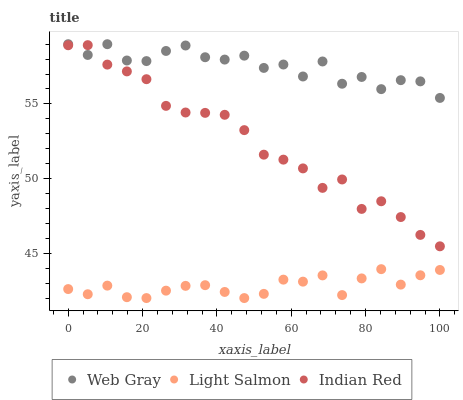Does Light Salmon have the minimum area under the curve?
Answer yes or no. Yes. Does Web Gray have the maximum area under the curve?
Answer yes or no. Yes. Does Indian Red have the minimum area under the curve?
Answer yes or no. No. Does Indian Red have the maximum area under the curve?
Answer yes or no. No. Is Light Salmon the smoothest?
Answer yes or no. Yes. Is Web Gray the roughest?
Answer yes or no. Yes. Is Indian Red the smoothest?
Answer yes or no. No. Is Indian Red the roughest?
Answer yes or no. No. Does Light Salmon have the lowest value?
Answer yes or no. Yes. Does Indian Red have the lowest value?
Answer yes or no. No. Does Web Gray have the highest value?
Answer yes or no. Yes. Does Indian Red have the highest value?
Answer yes or no. No. Is Light Salmon less than Indian Red?
Answer yes or no. Yes. Is Indian Red greater than Light Salmon?
Answer yes or no. Yes. Does Indian Red intersect Web Gray?
Answer yes or no. Yes. Is Indian Red less than Web Gray?
Answer yes or no. No. Is Indian Red greater than Web Gray?
Answer yes or no. No. Does Light Salmon intersect Indian Red?
Answer yes or no. No. 